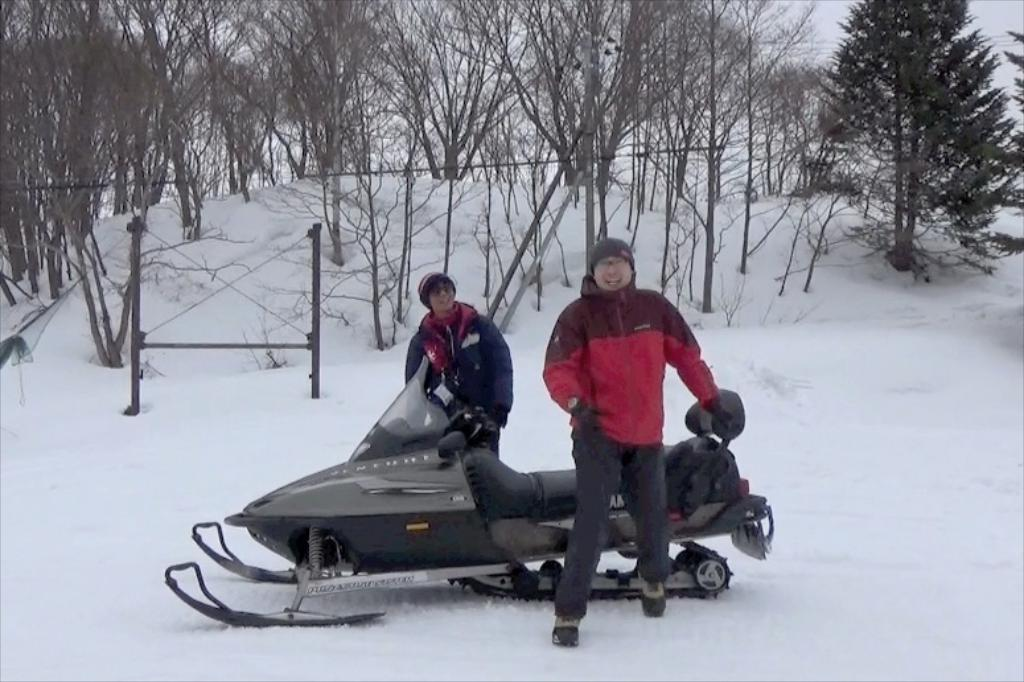How many people are in the image? There are two men standing in the image. What vehicle is present in the image? There is a snowmobile in the image. What is the ground covered with in the image? There is snow on the floor in the image. What can be seen in the distance in the image? There are objects and trees visible in the backdrop of the image. Where is the bottle of water placed in the image? There is no bottle of water present in the image. Can you see any dinosaurs in the image? There are no dinosaurs present in the image. 